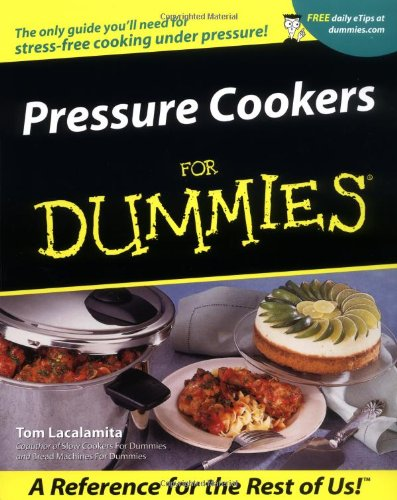Does this book include tips for first-time pressure cooker users? Yes, the book provides numerous tips and safety instructions to help first-time users get comfortable with cooking under pressure, ensuring they can do so safely and effectively. 